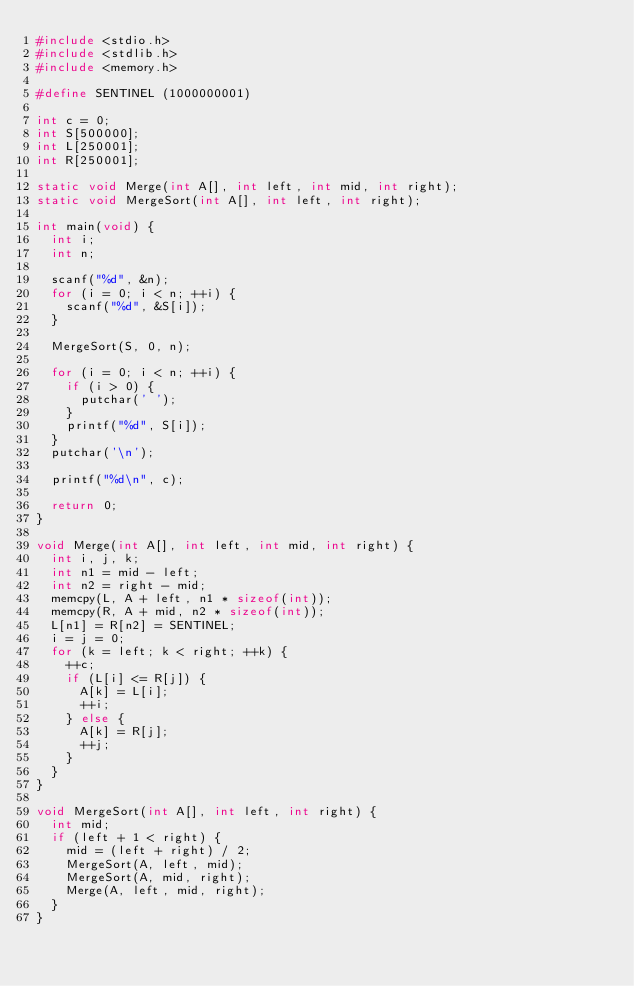<code> <loc_0><loc_0><loc_500><loc_500><_C_>#include <stdio.h>
#include <stdlib.h>
#include <memory.h>

#define SENTINEL (1000000001)

int c = 0;
int S[500000];
int L[250001];
int R[250001];

static void Merge(int A[], int left, int mid, int right);
static void MergeSort(int A[], int left, int right);

int main(void) {
	int i;
	int n;
	
	scanf("%d", &n);
	for (i = 0; i < n; ++i) {
		scanf("%d", &S[i]);
	}
	
	MergeSort(S, 0, n);
	
	for (i = 0; i < n; ++i) {
		if (i > 0) {
			putchar(' ');
		}
		printf("%d", S[i]);
	}
	putchar('\n');
	
	printf("%d\n", c);

	return 0;
}

void Merge(int A[], int left, int mid, int right) {
	int i, j, k;
	int n1 = mid - left;
	int n2 = right - mid;
	memcpy(L, A + left, n1 * sizeof(int));
	memcpy(R, A + mid, n2 * sizeof(int));
	L[n1] = R[n2] = SENTINEL;
	i = j = 0;
	for (k = left; k < right; ++k) {
		++c;
		if (L[i] <= R[j]) {
			A[k] = L[i];
			++i;
		} else {
			A[k] = R[j];
			++j;
		}
	}
}

void MergeSort(int A[], int left, int right) {
	int mid;
	if (left + 1 < right) {
		mid = (left + right) / 2;
		MergeSort(A, left, mid);
		MergeSort(A, mid, right);
		Merge(A, left, mid, right);
	}
}</code> 